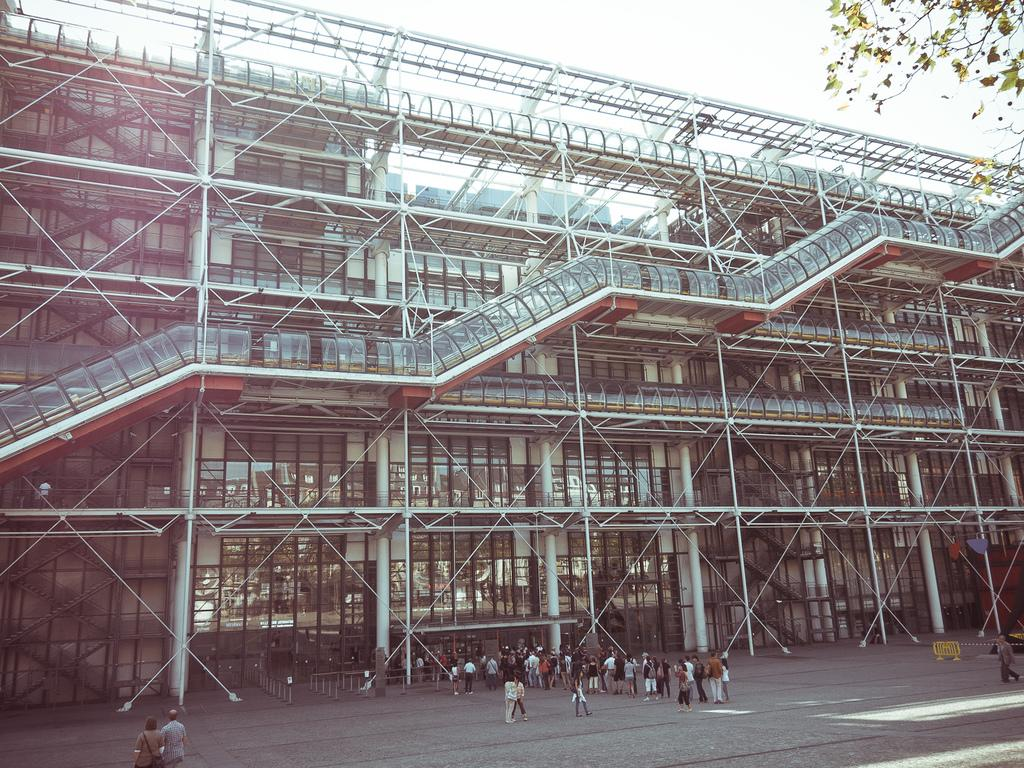What type of structure is present in the image? There is a building in the image. What else can be seen on the land in the image? There are people standing on the land in the image. What type of vegetation is on the right side of the image? There is a tree on the right side of the image. What is visible in the background of the image? The sky is visible in the background of the image. How many pizzas are being served to the dog in the image? There are no pizzas or dogs present in the image. What type of toad can be seen sitting on the tree in the image? There is no toad present in the image; only a tree is visible on the right side. 